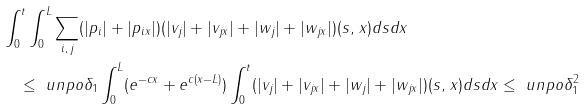<formula> <loc_0><loc_0><loc_500><loc_500>& \int _ { 0 } ^ { t } \int _ { 0 } ^ { L } \sum _ { i , \, j } ( | p _ { i } | + | p _ { i x } | ) ( | v _ { j } | + | v _ { j x } | + | w _ { j } | + | w _ { j x } | ) ( s , \, x ) d s d x \\ & \quad \leq \ u n p o \delta _ { 1 } \int _ { 0 } ^ { L } ( e ^ { - c x } + e ^ { c ( x - L ) } ) \int _ { 0 } ^ { t } ( | v _ { j } | + | v _ { j x } | + | w _ { j } | + | w _ { j x } | ) ( s , \, x ) d s d x \leq \ u n p o \delta _ { 1 } ^ { 2 } \\</formula> 